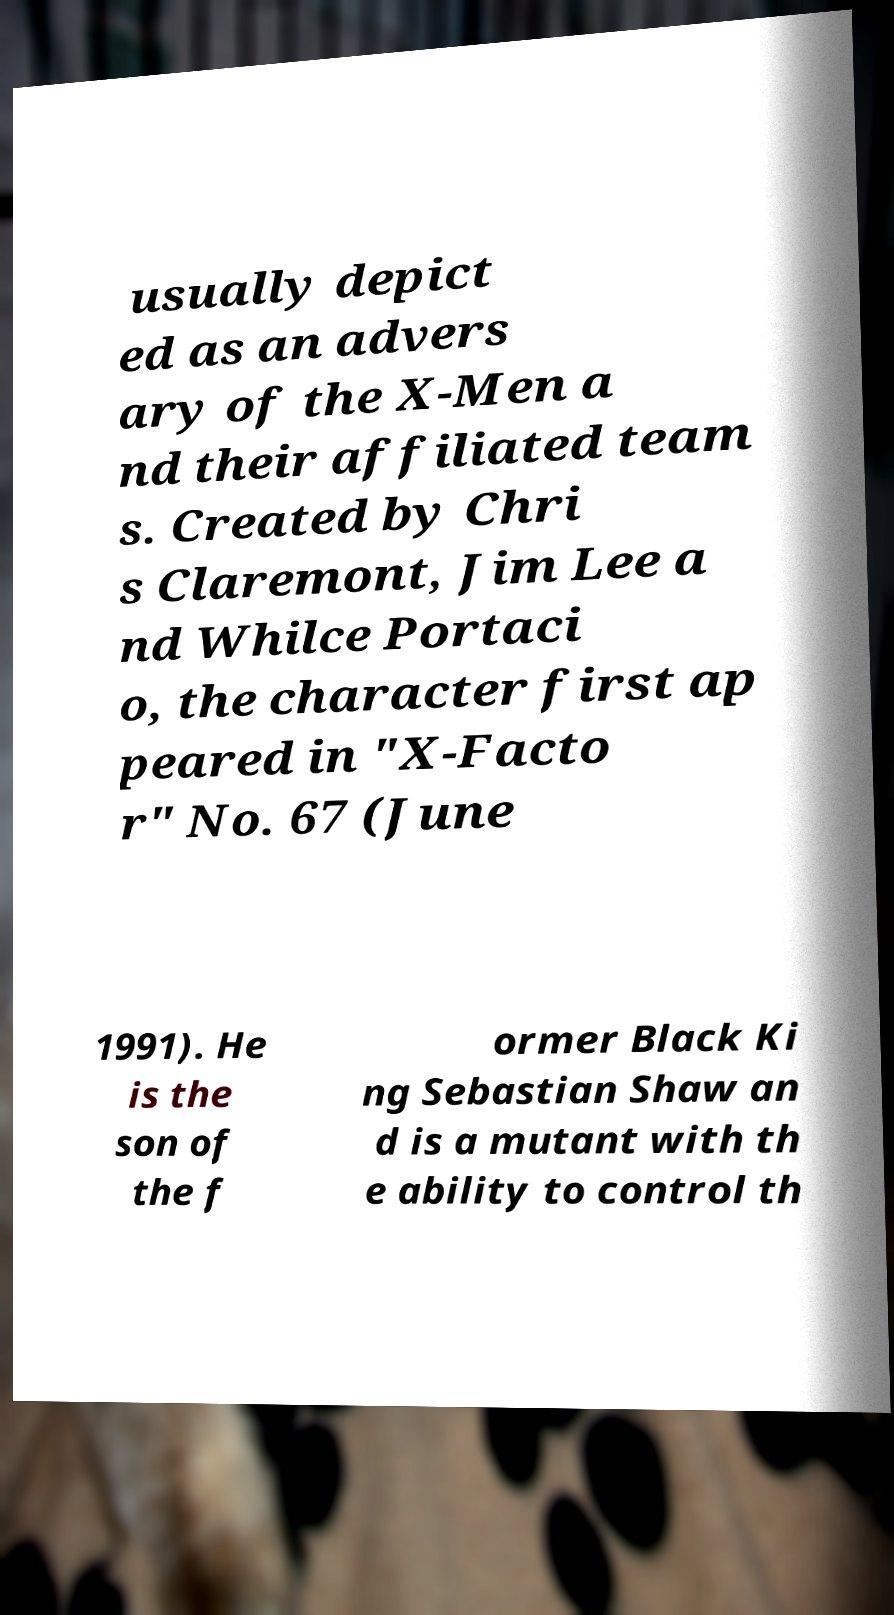There's text embedded in this image that I need extracted. Can you transcribe it verbatim? usually depict ed as an advers ary of the X-Men a nd their affiliated team s. Created by Chri s Claremont, Jim Lee a nd Whilce Portaci o, the character first ap peared in "X-Facto r" No. 67 (June 1991). He is the son of the f ormer Black Ki ng Sebastian Shaw an d is a mutant with th e ability to control th 